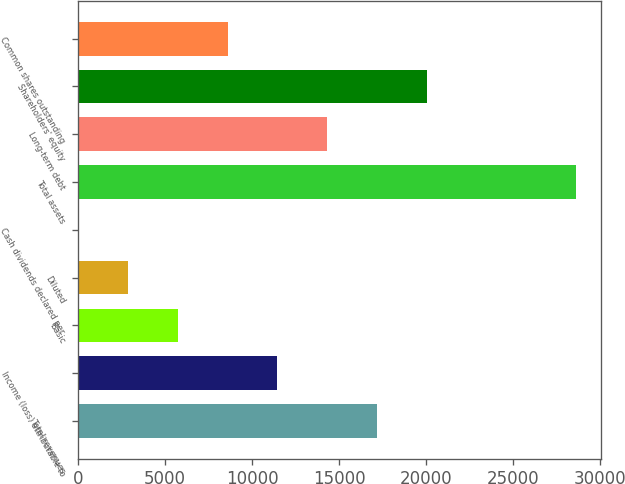Convert chart to OTSL. <chart><loc_0><loc_0><loc_500><loc_500><bar_chart><fcel>Total revenues<fcel>Income (loss) attributable to<fcel>Basic<fcel>Diluted<fcel>Cash dividends declared per<fcel>Total assets<fcel>Long-term debt<fcel>Shareholders' equity<fcel>Common shares outstanding<nl><fcel>17181.2<fcel>11454.4<fcel>5727.48<fcel>2864.04<fcel>0.6<fcel>28635<fcel>14317.8<fcel>20044.7<fcel>8590.92<nl></chart> 